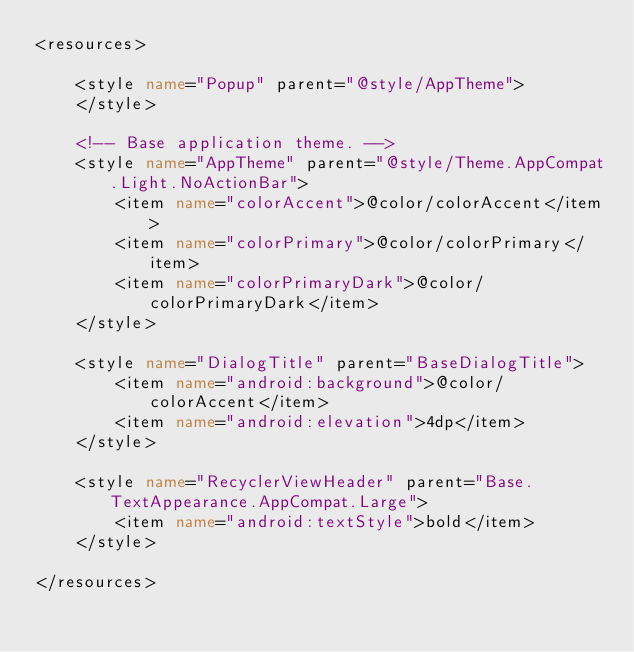<code> <loc_0><loc_0><loc_500><loc_500><_XML_><resources>

    <style name="Popup" parent="@style/AppTheme">
    </style>

    <!-- Base application theme. -->
    <style name="AppTheme" parent="@style/Theme.AppCompat.Light.NoActionBar">
        <item name="colorAccent">@color/colorAccent</item>
        <item name="colorPrimary">@color/colorPrimary</item>
        <item name="colorPrimaryDark">@color/colorPrimaryDark</item>
    </style>

    <style name="DialogTitle" parent="BaseDialogTitle">
        <item name="android:background">@color/colorAccent</item>
        <item name="android:elevation">4dp</item>
    </style>

    <style name="RecyclerViewHeader" parent="Base.TextAppearance.AppCompat.Large">
        <item name="android:textStyle">bold</item>
    </style>

</resources>
</code> 